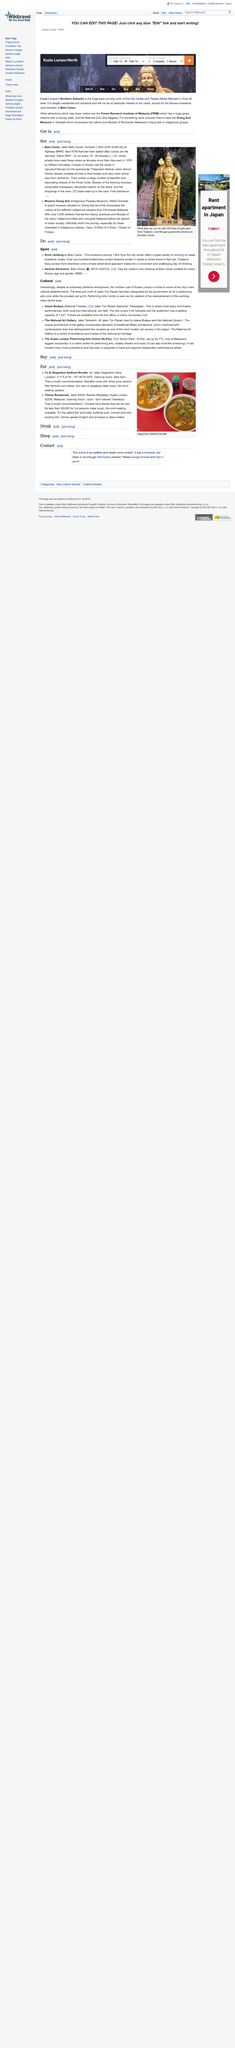Draw attention to some important aspects in this diagram. William Hornaday discovered the Batu Caves. Yu Ai Segambut Seafood Noodle is open from 8am to 5pm. The statue shown in the picture is Lord Murugan. The Indigenous Peoples Museum showcases the rich culture of the various indigenous communities from Peninsular Malaysia, providing visitors with a comprehensive understanding of their traditions, customs, and way of life. Theme Restaurant specializes in serving Chinese cuisine. 